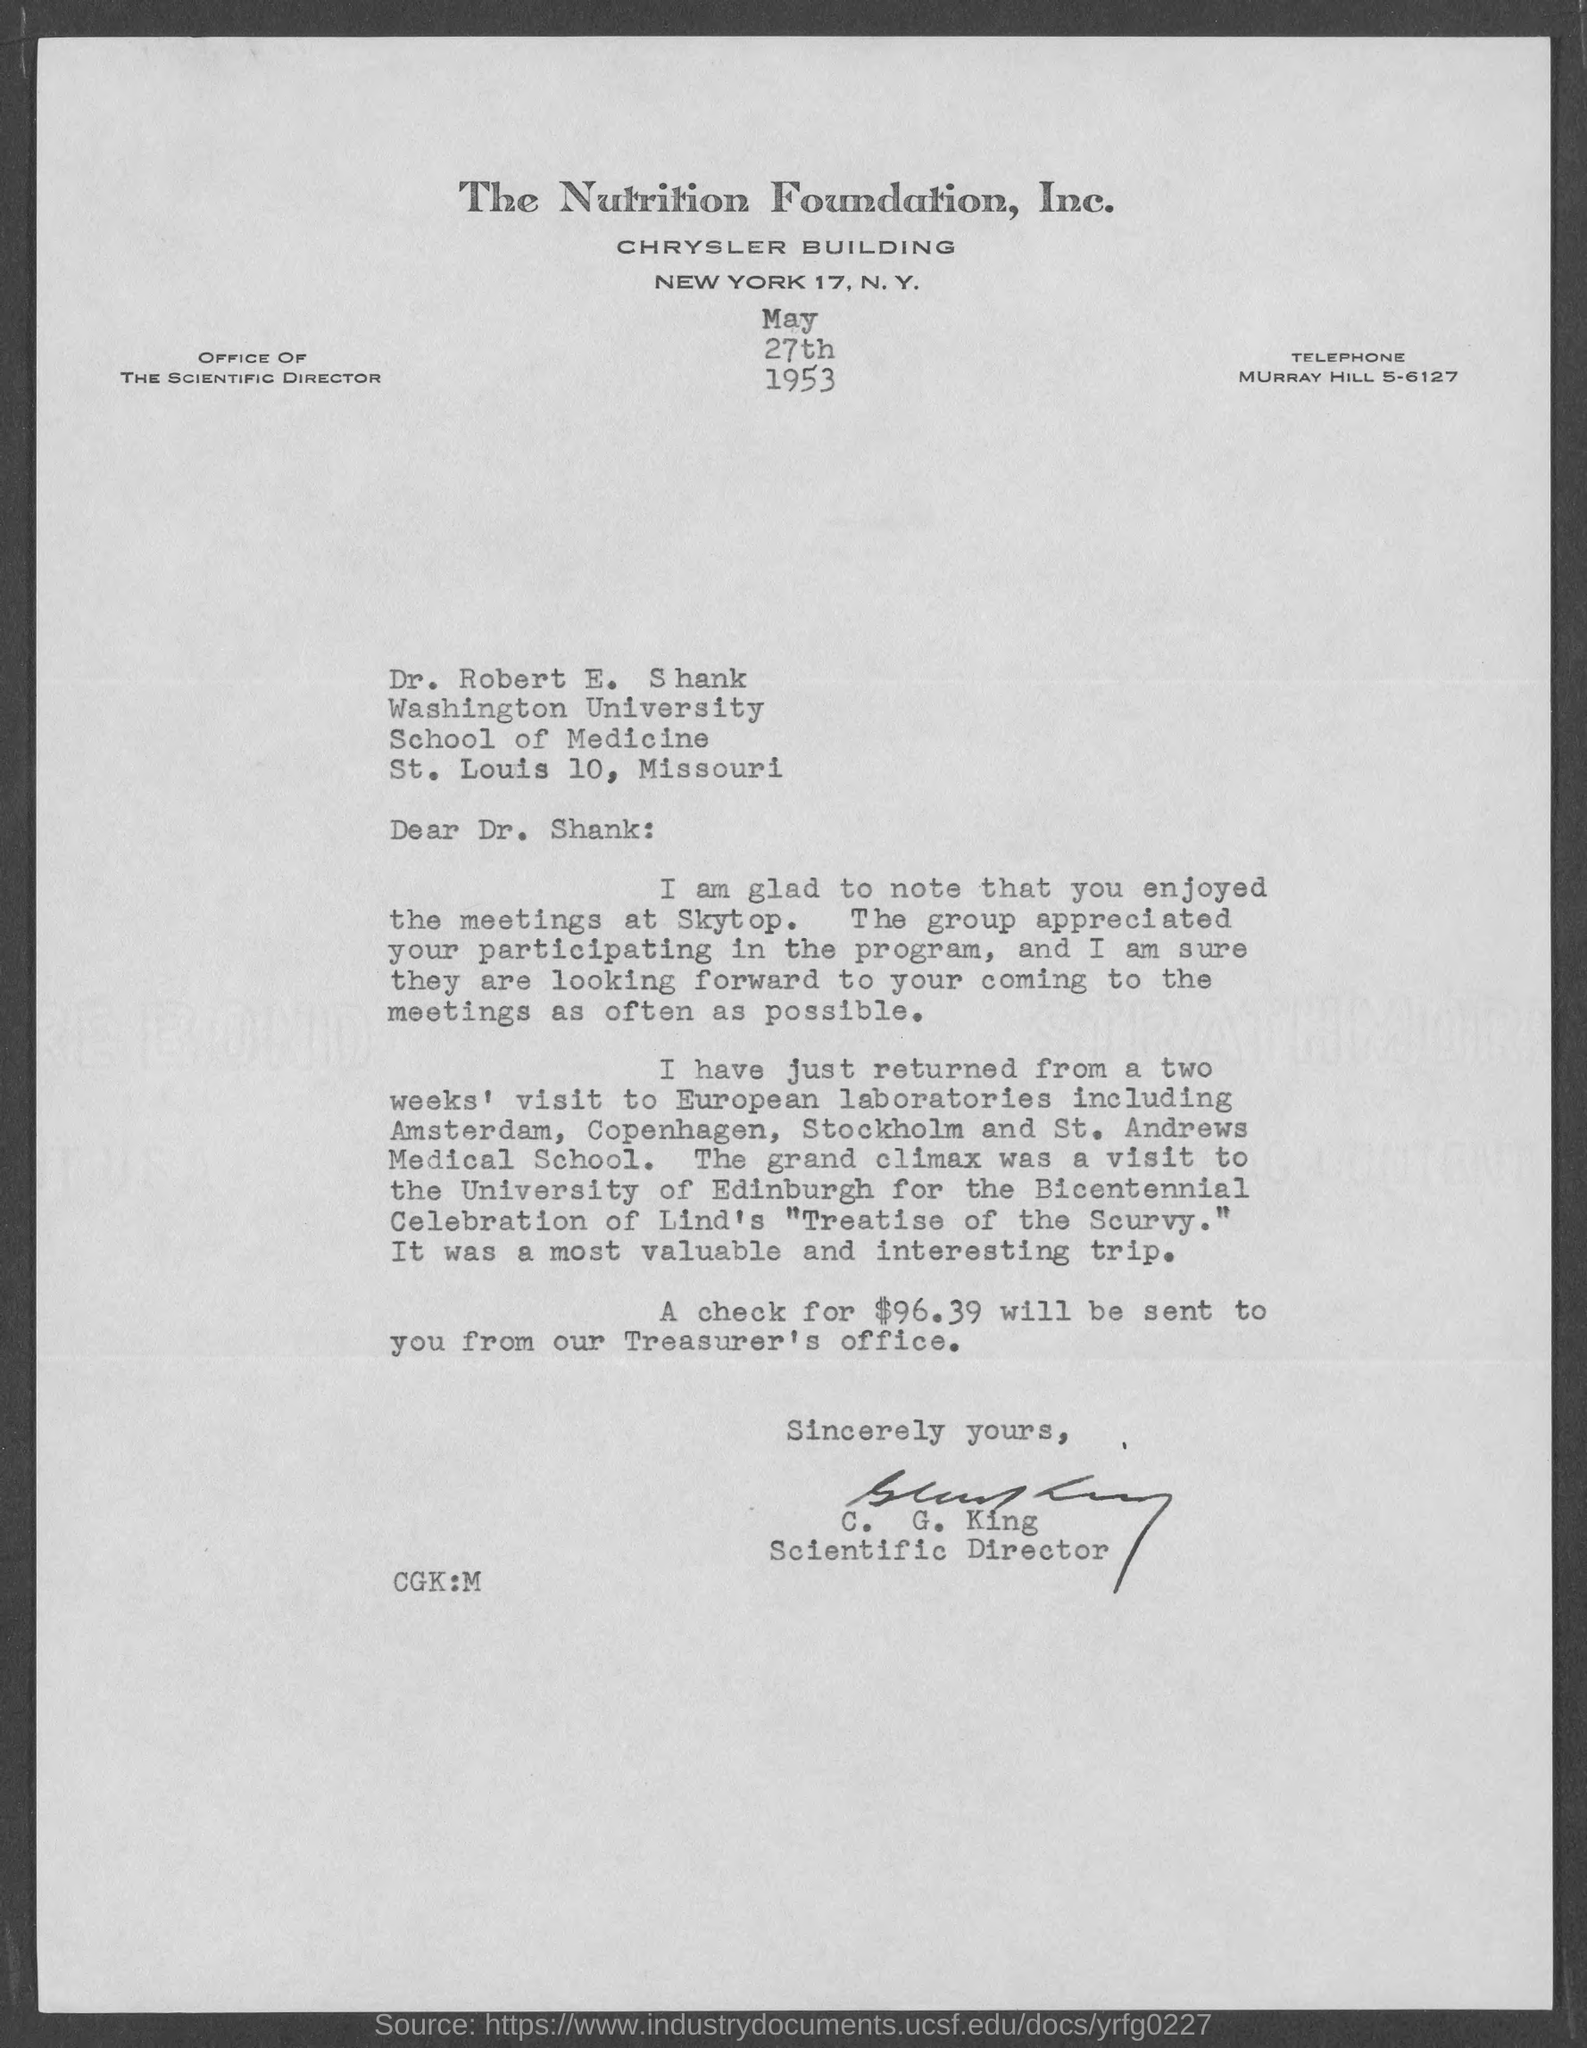To whom this letter is written to?
Offer a terse response. Dr. Robert E. Shank. What is the amount of check that would be sent from treasurer's office?
Make the answer very short. $96.39. 